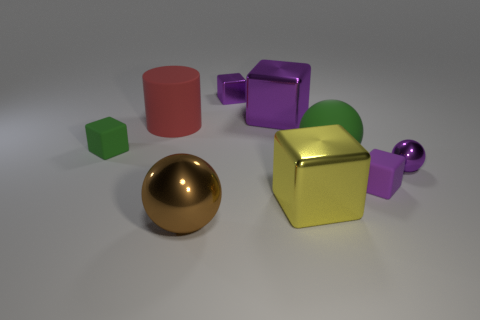What is the size of the matte cube that is the same color as the tiny metallic ball?
Provide a succinct answer. Small. What shape is the green rubber thing that is on the right side of the sphere that is to the left of the big object behind the red matte cylinder?
Your answer should be very brief. Sphere. What number of red things are either tiny shiny things or matte objects?
Provide a short and direct response. 1. There is a big sphere behind the yellow thing; how many yellow things are in front of it?
Your answer should be compact. 1. Are there any other things of the same color as the cylinder?
Offer a terse response. No. There is a green object that is the same material as the green ball; what is its shape?
Ensure brevity in your answer.  Cube. Does the big matte cylinder have the same color as the tiny metallic sphere?
Give a very brief answer. No. Are the small block in front of the small purple ball and the brown thing in front of the small ball made of the same material?
Ensure brevity in your answer.  No. What number of things are cyan rubber blocks or large matte objects behind the yellow metallic object?
Your answer should be very brief. 2. Is there anything else that is the same material as the small ball?
Offer a very short reply. Yes. 